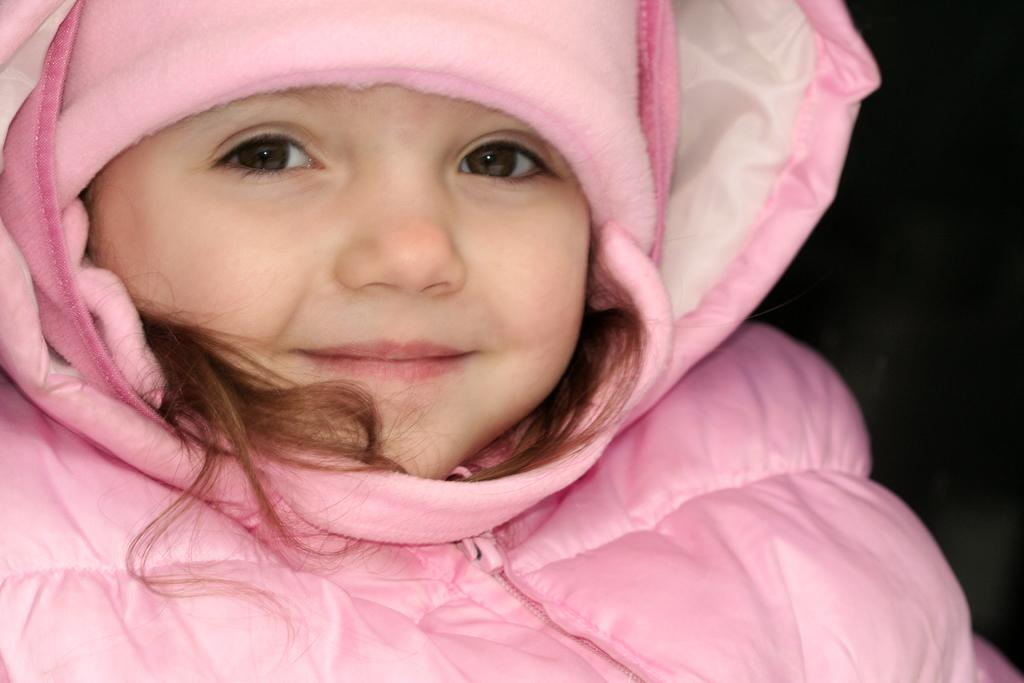Who is the main subject in the image? There is a girl in the image. What is the girl wearing? The girl is wearing a pink jacket. What is the girl's facial expression? The girl is smiling. What color are the girl's eyes? A: The girl has black eyes. What can be seen on the right side of the image? There is a black background on the right side of the image. What type of chairs are being discussed in the image? There is no mention of chairs or any discussion in the image; it features a girl with a smile and black eyes. 